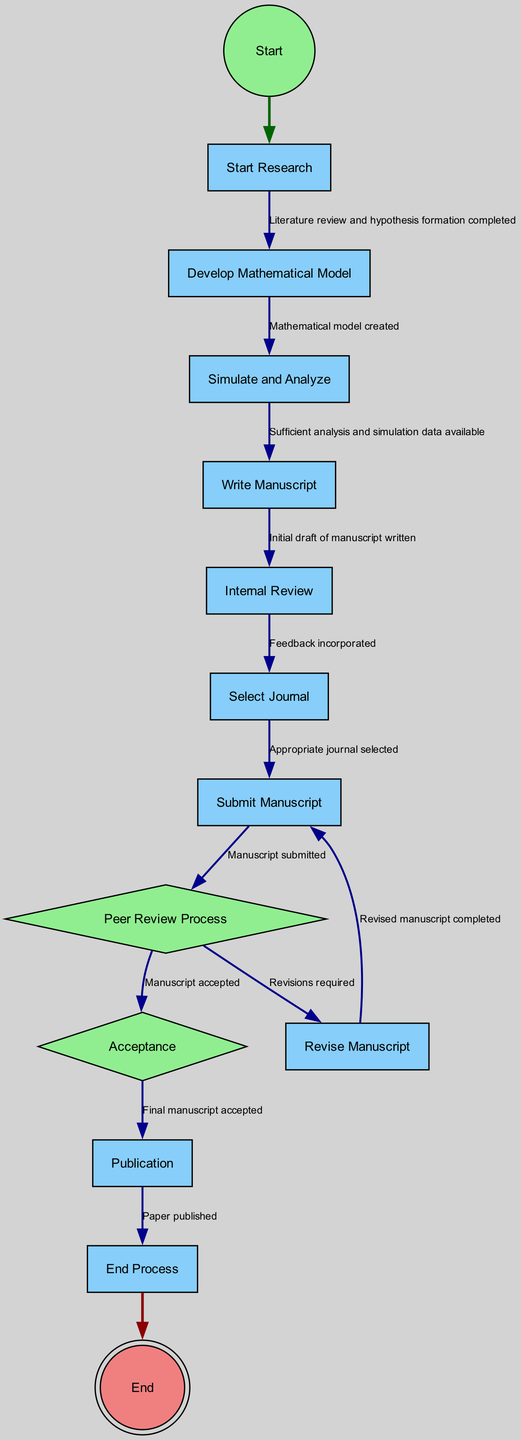What is the first activity in the publication process? The publication process begins with the "Start Research" activity, as it is indicated as the first node in the diagram.
Answer: Start Research How many activities are involved in the process? By counting the nodes categorized as activities, we find there are a total of 7 activities in the diagram.
Answer: 7 What is the final activity before the process ends? The last activity identified in the diagram before reaching the end is "Publication," which is the step where the paper is published in the journal.
Answer: Publication What decision follows the "Peer Review Process"? After the "Peer Review Process," there are two possible outcomes, one of which is "Acceptance," indicating that the manuscript has been accepted for publication.
Answer: Acceptance What is the condition for submitting the manuscript? The condition to reach the "Submit Manuscript" activity is that an appropriate journal must be selected beforehand, as indicated by the transition from "Select Journal" to "Submit Manuscript."
Answer: Appropriate journal selected If revisions are required, what activity must be performed next? If the decision made during the "Peer Review Process" is that revisions are needed, the next activity to be performed is "Revise Manuscript" before potentially resubmitting the manuscript.
Answer: Revise Manuscript What do you do after receiving acceptance notification? Upon receiving the acceptance notification, the next task in the flow is to proceed to the "Publication" activity, marking the transition from acceptance to the paper being published.
Answer: Publication What is the starting point of the diagram represented as? In the diagram, the starting point is represented as a circle labeled "Start," indicating where the process initiates.
Answer: Start What must be completed before writing the manuscript? Before proceeding to write the manuscript, sufficient analysis and simulation data must be available, as outlined in the transition from "Simulate and Analyze" to "Write Manuscript."
Answer: Sufficient analysis and simulation data available 